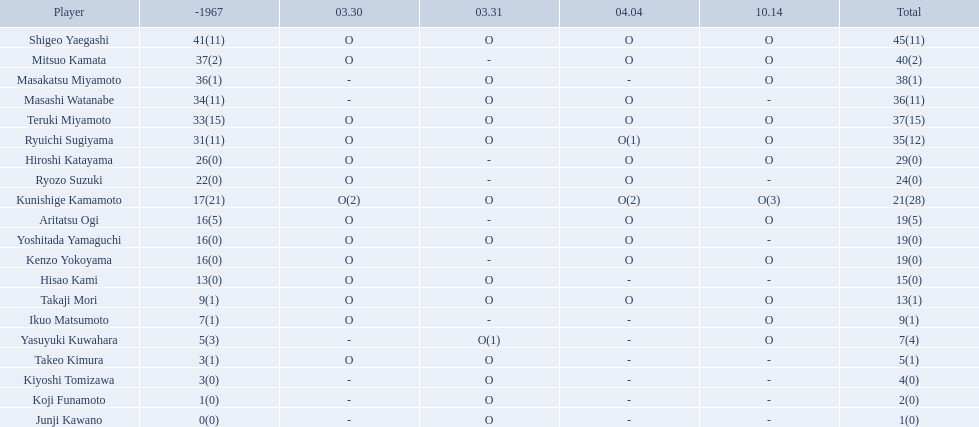Who were the players in the 1968 japanese football? Shigeo Yaegashi, Mitsuo Kamata, Masakatsu Miyamoto, Masashi Watanabe, Teruki Miyamoto, Ryuichi Sugiyama, Hiroshi Katayama, Ryozo Suzuki, Kunishige Kamamoto, Aritatsu Ogi, Yoshitada Yamaguchi, Kenzo Yokoyama, Hisao Kami, Takaji Mori, Ikuo Matsumoto, Yasuyuki Kuwahara, Takeo Kimura, Kiyoshi Tomizawa, Koji Funamoto, Junji Kawano. How many points total did takaji mori have? 13(1). How many points total did junju kawano? 1(0). Who had more points? Takaji Mori. How many points did takaji mori have? 13(1). And how many points did junji kawano have? 1(0). To who does the higher of these belong to? Takaji Mori. 